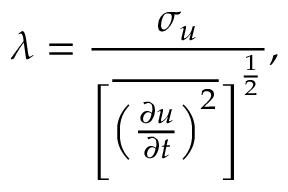<formula> <loc_0><loc_0><loc_500><loc_500>\lambda = \frac { \sigma _ { u } } { { \left [ \overline { { { \left ( \frac { \partial u } { \partial t } \right ) ^ { 2 } } } } \right ] } ^ { \frac { 1 } { 2 } } } ,</formula> 